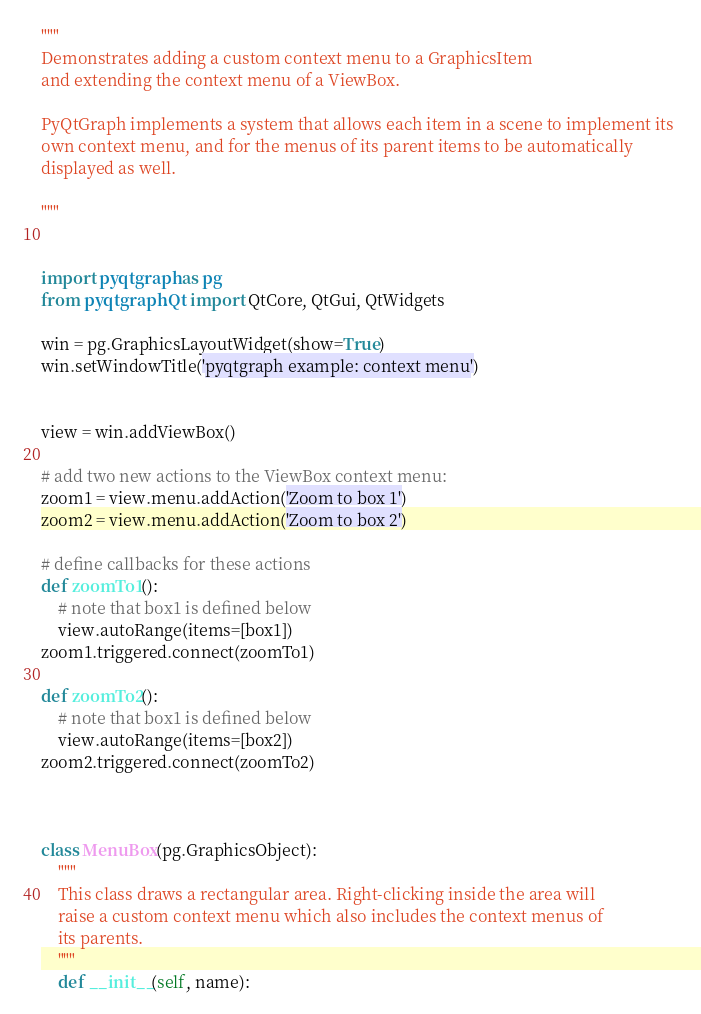Convert code to text. <code><loc_0><loc_0><loc_500><loc_500><_Python_>"""
Demonstrates adding a custom context menu to a GraphicsItem
and extending the context menu of a ViewBox.

PyQtGraph implements a system that allows each item in a scene to implement its 
own context menu, and for the menus of its parent items to be automatically 
displayed as well. 

"""


import pyqtgraph as pg
from pyqtgraph.Qt import QtCore, QtGui, QtWidgets

win = pg.GraphicsLayoutWidget(show=True)
win.setWindowTitle('pyqtgraph example: context menu')


view = win.addViewBox()

# add two new actions to the ViewBox context menu:
zoom1 = view.menu.addAction('Zoom to box 1')
zoom2 = view.menu.addAction('Zoom to box 2')

# define callbacks for these actions
def zoomTo1():
    # note that box1 is defined below
    view.autoRange(items=[box1])
zoom1.triggered.connect(zoomTo1)

def zoomTo2():
    # note that box1 is defined below
    view.autoRange(items=[box2])
zoom2.triggered.connect(zoomTo2)



class MenuBox(pg.GraphicsObject):
    """
    This class draws a rectangular area. Right-clicking inside the area will
    raise a custom context menu which also includes the context menus of
    its parents.    
    """
    def __init__(self, name):</code> 